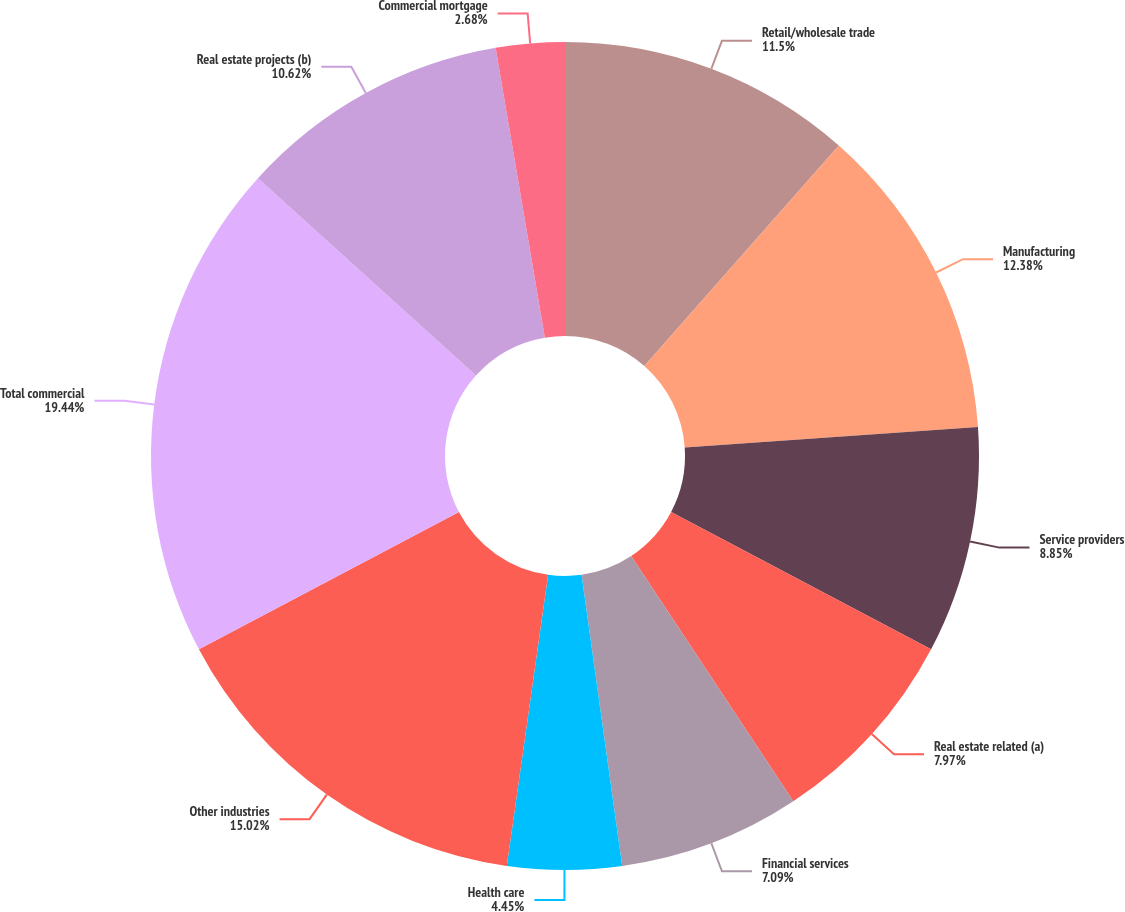<chart> <loc_0><loc_0><loc_500><loc_500><pie_chart><fcel>Retail/wholesale trade<fcel>Manufacturing<fcel>Service providers<fcel>Real estate related (a)<fcel>Financial services<fcel>Health care<fcel>Other industries<fcel>Total commercial<fcel>Real estate projects (b)<fcel>Commercial mortgage<nl><fcel>11.5%<fcel>12.38%<fcel>8.85%<fcel>7.97%<fcel>7.09%<fcel>4.45%<fcel>15.02%<fcel>19.43%<fcel>10.62%<fcel>2.68%<nl></chart> 